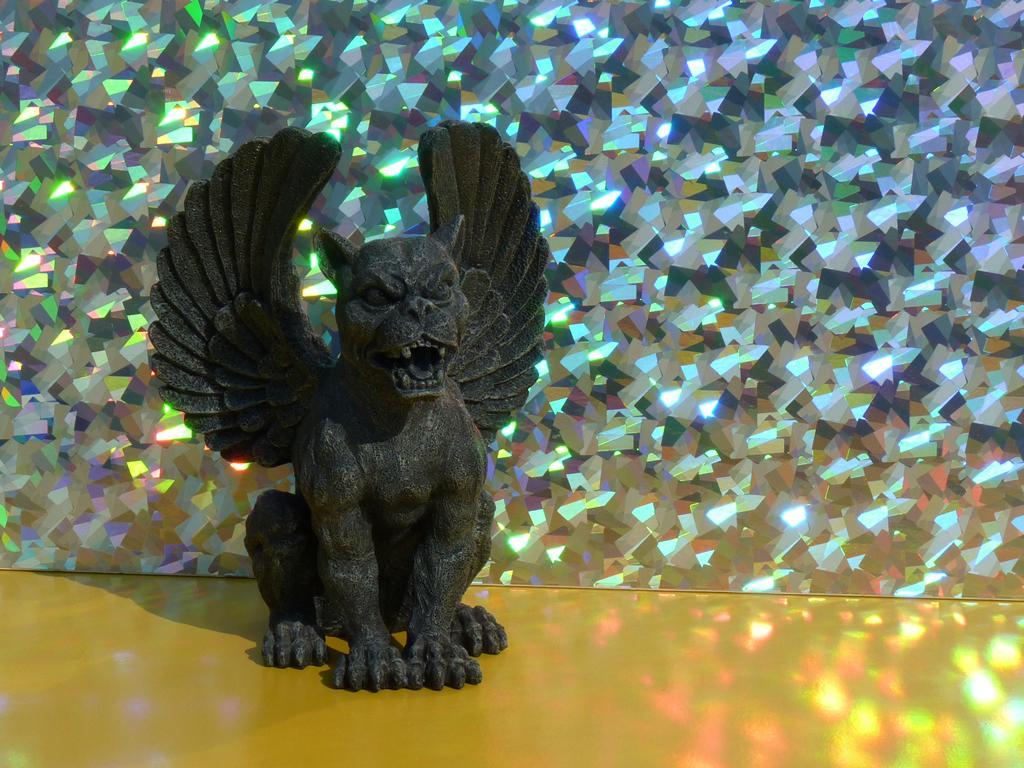Describe this image in one or two sentences. In this image in the front there is a statute which is black in colour. In the background there is an object which is shining. 